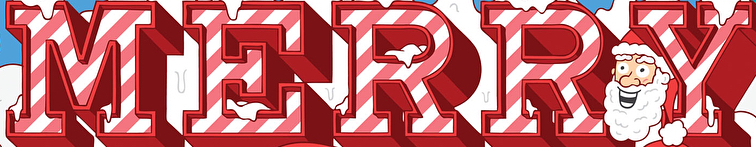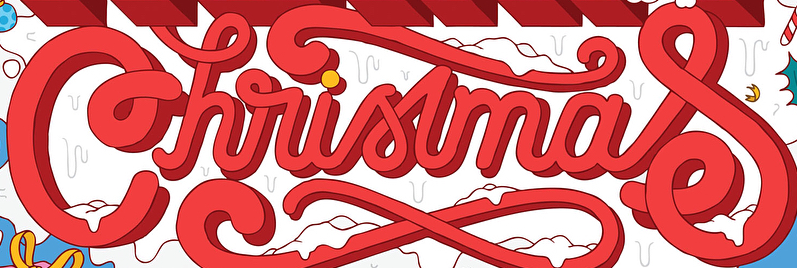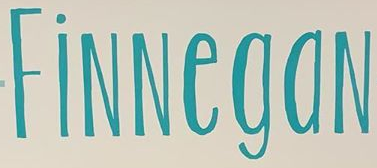What text appears in these images from left to right, separated by a semicolon? MERRY; Christmas; FiNNegaN 